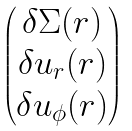<formula> <loc_0><loc_0><loc_500><loc_500>\begin{pmatrix} \begin{matrix} \delta \Sigma ( r ) \\ \delta u _ { r } ( r ) \\ \delta u _ { \phi } ( r ) \end{matrix} \end{pmatrix}</formula> 